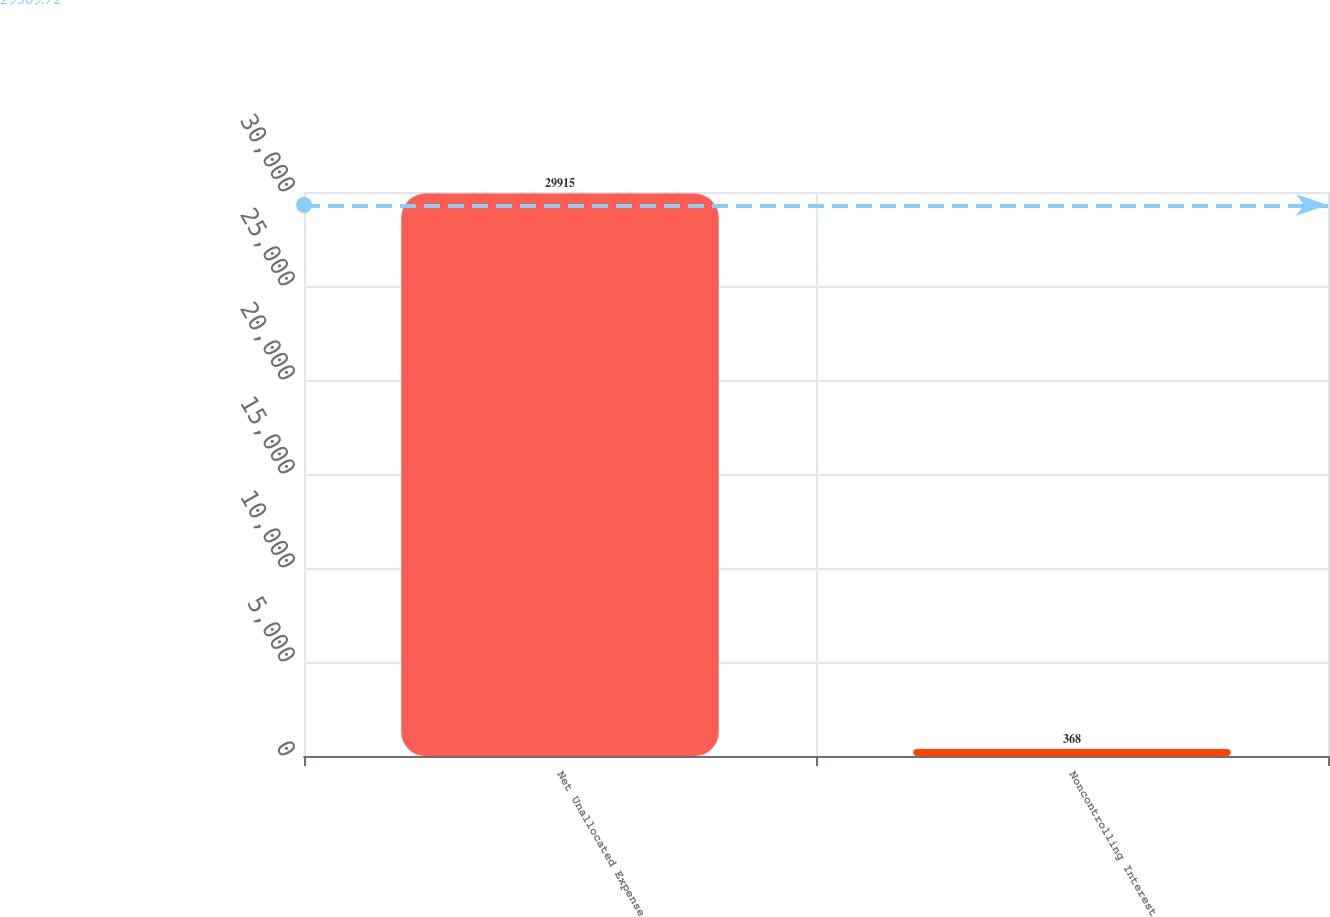Convert chart to OTSL. <chart><loc_0><loc_0><loc_500><loc_500><bar_chart><fcel>Net Unallocated Expense<fcel>Noncontrolling Interest<nl><fcel>29915<fcel>368<nl></chart> 